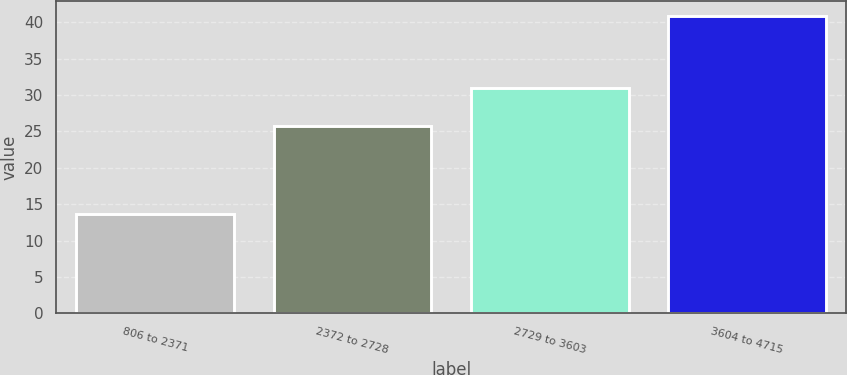<chart> <loc_0><loc_0><loc_500><loc_500><bar_chart><fcel>806 to 2371<fcel>2372 to 2728<fcel>2729 to 3603<fcel>3604 to 4715<nl><fcel>13.62<fcel>25.71<fcel>30.95<fcel>40.88<nl></chart> 